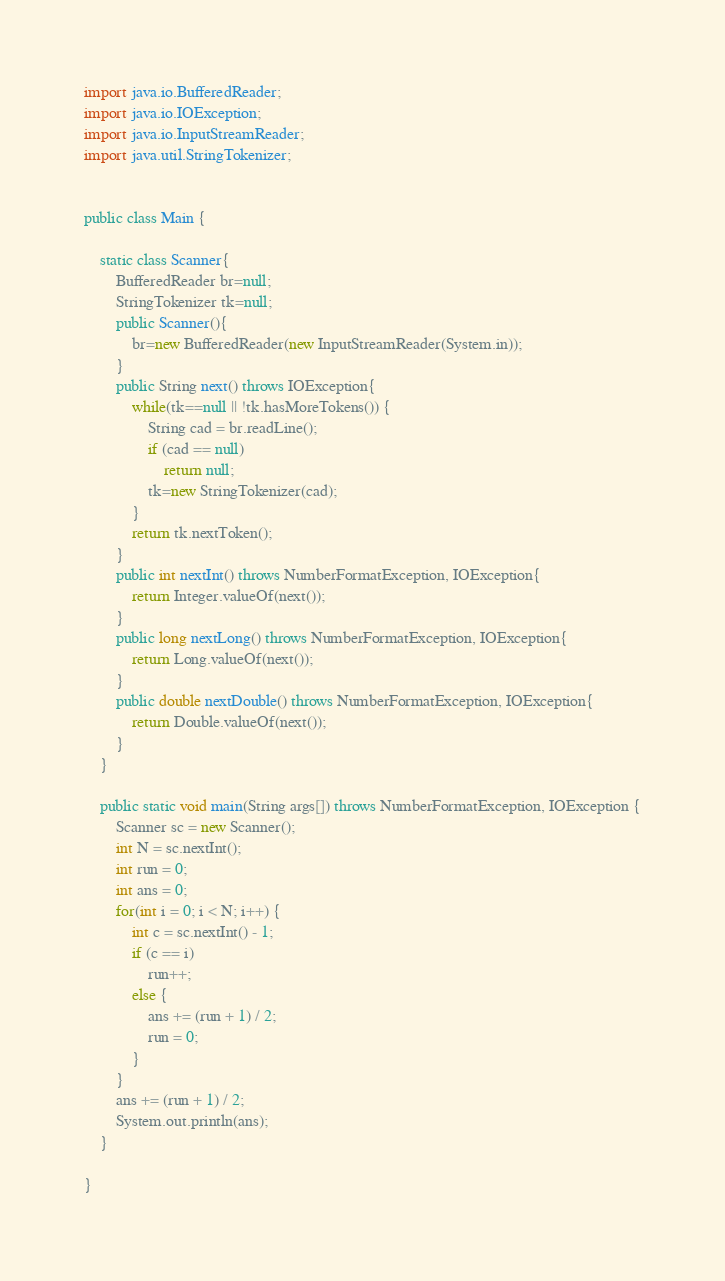<code> <loc_0><loc_0><loc_500><loc_500><_Java_>import java.io.BufferedReader;
import java.io.IOException;
import java.io.InputStreamReader;
import java.util.StringTokenizer;


public class Main {
	
	static class Scanner{
		BufferedReader br=null;
		StringTokenizer tk=null;
		public Scanner(){
			br=new BufferedReader(new InputStreamReader(System.in));
		}
		public String next() throws IOException{
			while(tk==null || !tk.hasMoreTokens()) {
				String cad = br.readLine();
				if (cad == null)
					return null;
				tk=new StringTokenizer(cad);
			}
			return tk.nextToken();
		}
		public int nextInt() throws NumberFormatException, IOException{
			return Integer.valueOf(next());
		}
		public long nextLong() throws NumberFormatException, IOException{
			return Long.valueOf(next());
		}
		public double nextDouble() throws NumberFormatException, IOException{
			return Double.valueOf(next());
		}
	}
	
	public static void main(String args[]) throws NumberFormatException, IOException {
		Scanner sc = new Scanner();
		int N = sc.nextInt();
		int run = 0;
		int ans = 0;
		for(int i = 0; i < N; i++) {
			int c = sc.nextInt() - 1;
			if (c == i)
				run++;
			else {
				ans += (run + 1) / 2;
				run = 0;
			}
		}
		ans += (run + 1) / 2;
		System.out.println(ans);
	}

}
</code> 